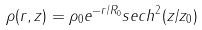<formula> <loc_0><loc_0><loc_500><loc_500>\rho ( r , z ) = \rho _ { 0 } e ^ { - r / R _ { 0 } } s e c h ^ { 2 } ( z / z _ { 0 } )</formula> 